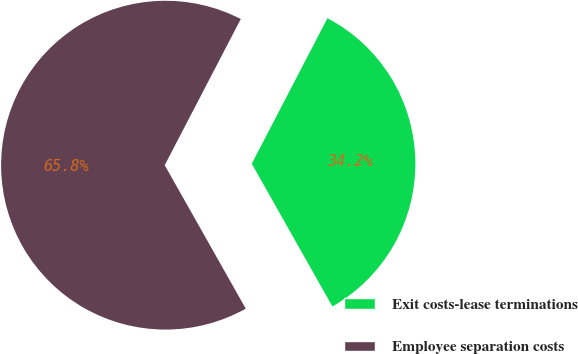<chart> <loc_0><loc_0><loc_500><loc_500><pie_chart><fcel>Exit costs-lease terminations<fcel>Employee separation costs<nl><fcel>34.18%<fcel>65.82%<nl></chart> 